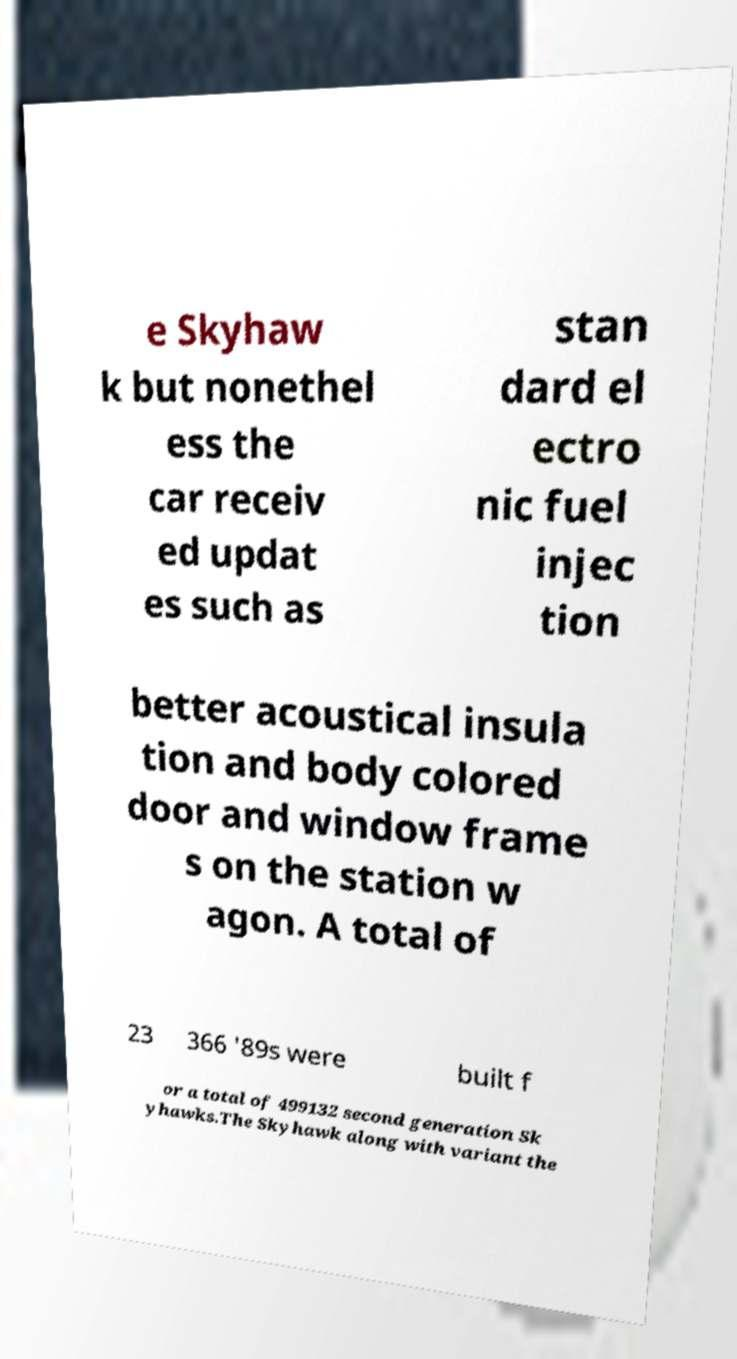Please identify and transcribe the text found in this image. e Skyhaw k but nonethel ess the car receiv ed updat es such as stan dard el ectro nic fuel injec tion better acoustical insula tion and body colored door and window frame s on the station w agon. A total of 23 366 '89s were built f or a total of 499132 second generation Sk yhawks.The Skyhawk along with variant the 